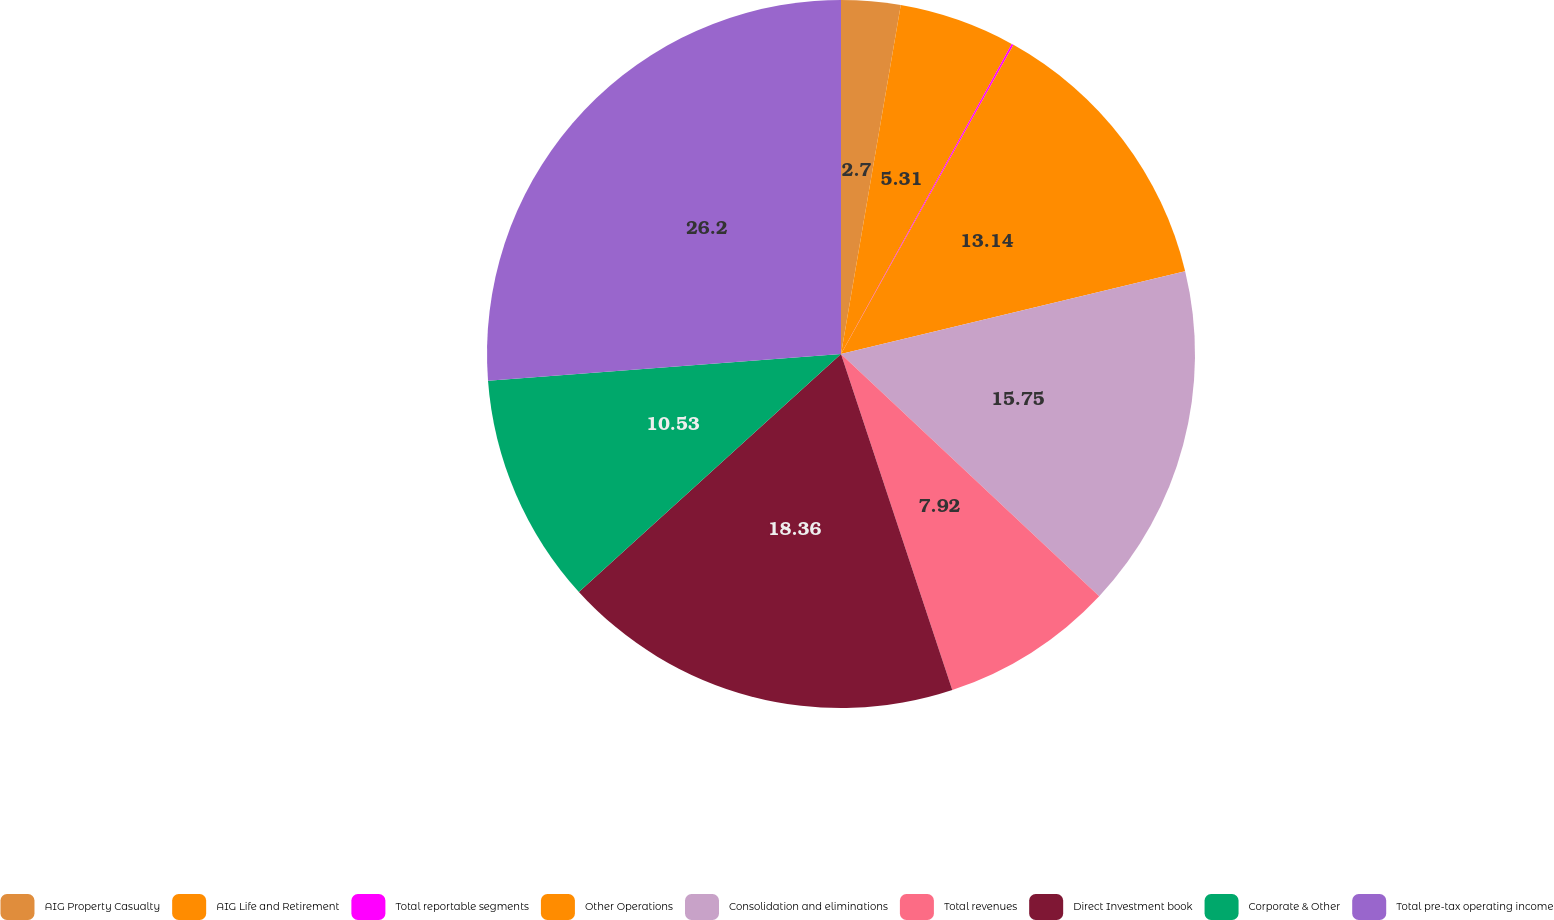<chart> <loc_0><loc_0><loc_500><loc_500><pie_chart><fcel>AIG Property Casualty<fcel>AIG Life and Retirement<fcel>Total reportable segments<fcel>Other Operations<fcel>Consolidation and eliminations<fcel>Total revenues<fcel>Direct Investment book<fcel>Corporate & Other<fcel>Total pre-tax operating income<nl><fcel>2.7%<fcel>5.31%<fcel>0.09%<fcel>13.14%<fcel>15.75%<fcel>7.92%<fcel>18.36%<fcel>10.53%<fcel>26.2%<nl></chart> 